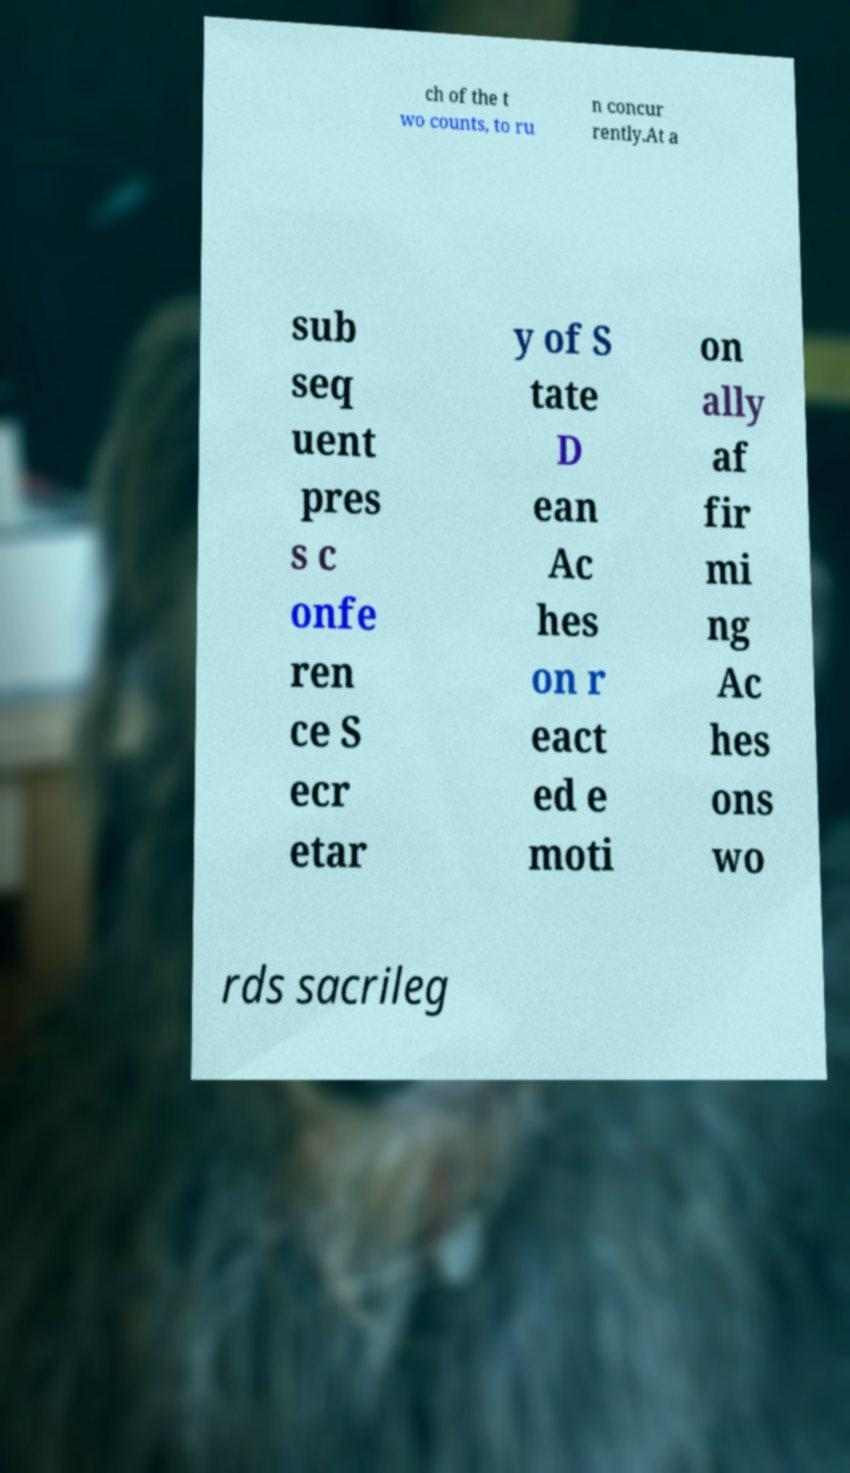Please read and relay the text visible in this image. What does it say? ch of the t wo counts, to ru n concur rently.At a sub seq uent pres s c onfe ren ce S ecr etar y of S tate D ean Ac hes on r eact ed e moti on ally af fir mi ng Ac hes ons wo rds sacrileg 